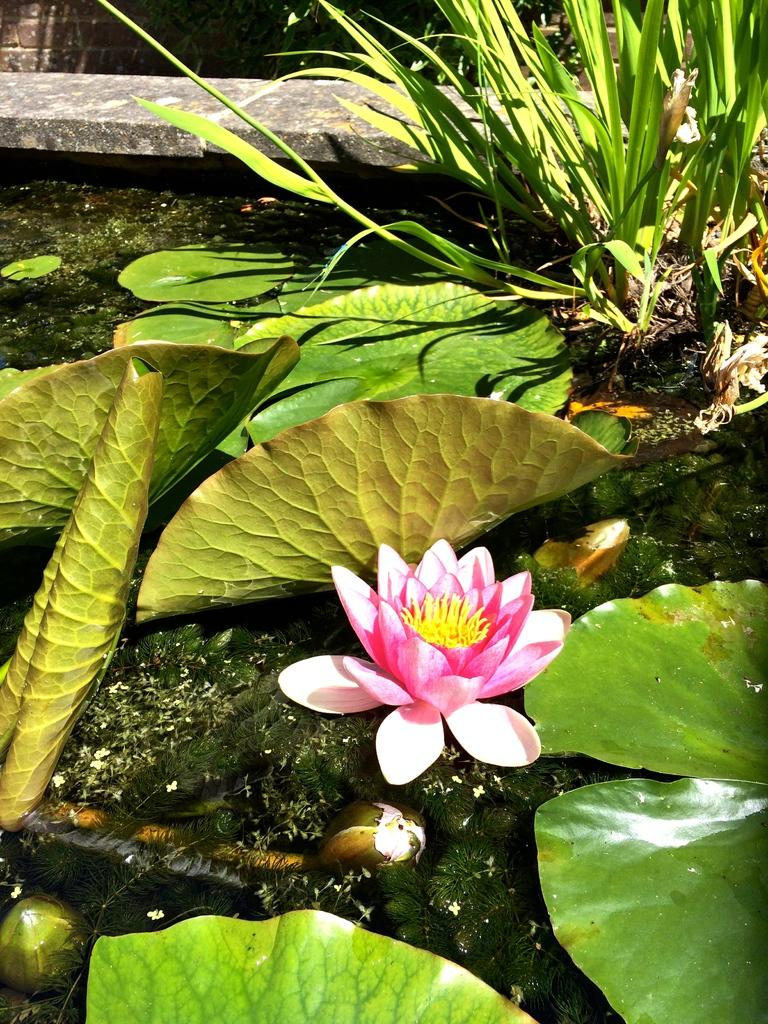What type of flower is in the image? There is a lotus flower in the image. What is the lotus flower situated on? The lotus flower is on leaves on water in the image. What can be seen in the background of the image? There are plants and stones in the background of the image. What type of structure is visible in the background? There is a wall in the background of the image. What type of shoes can be seen hanging from the wall in the image? There are no shoes present in the image; the wall is in the background and does not have any shoes hanging from it. 